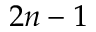Convert formula to latex. <formula><loc_0><loc_0><loc_500><loc_500>2 n - 1</formula> 